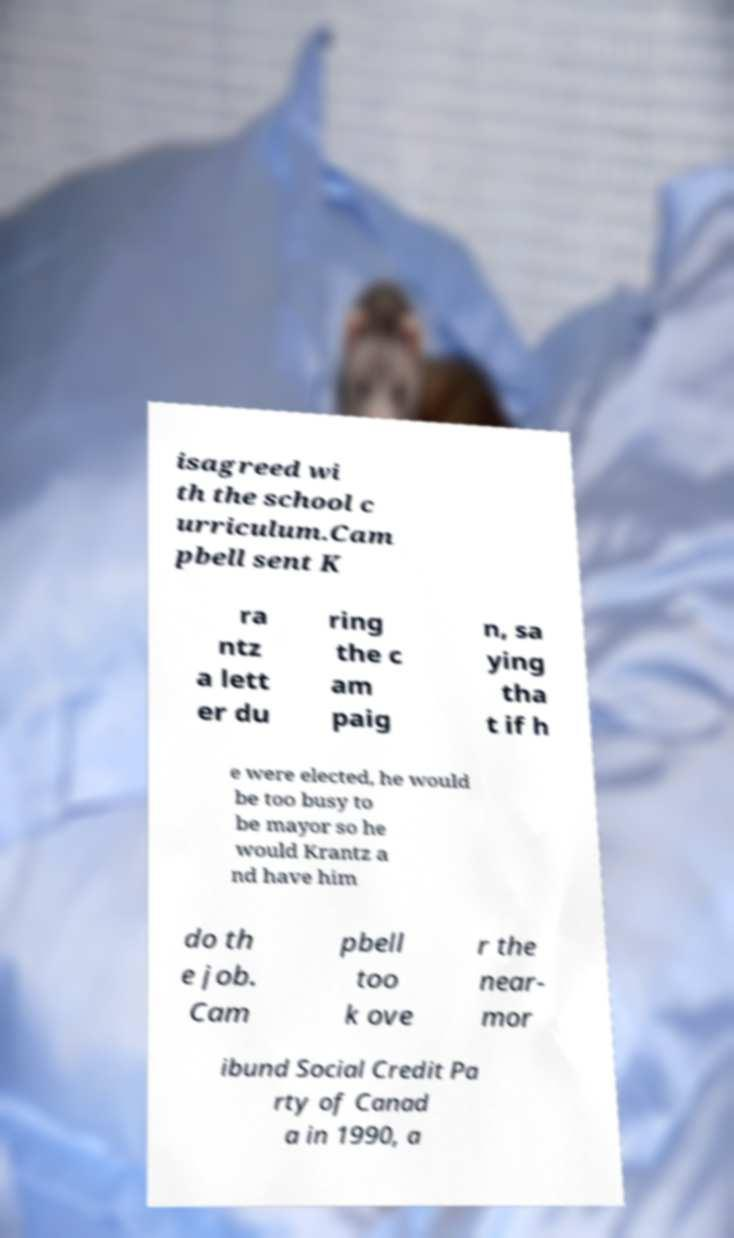Could you extract and type out the text from this image? isagreed wi th the school c urriculum.Cam pbell sent K ra ntz a lett er du ring the c am paig n, sa ying tha t if h e were elected, he would be too busy to be mayor so he would Krantz a nd have him do th e job. Cam pbell too k ove r the near- mor ibund Social Credit Pa rty of Canad a in 1990, a 